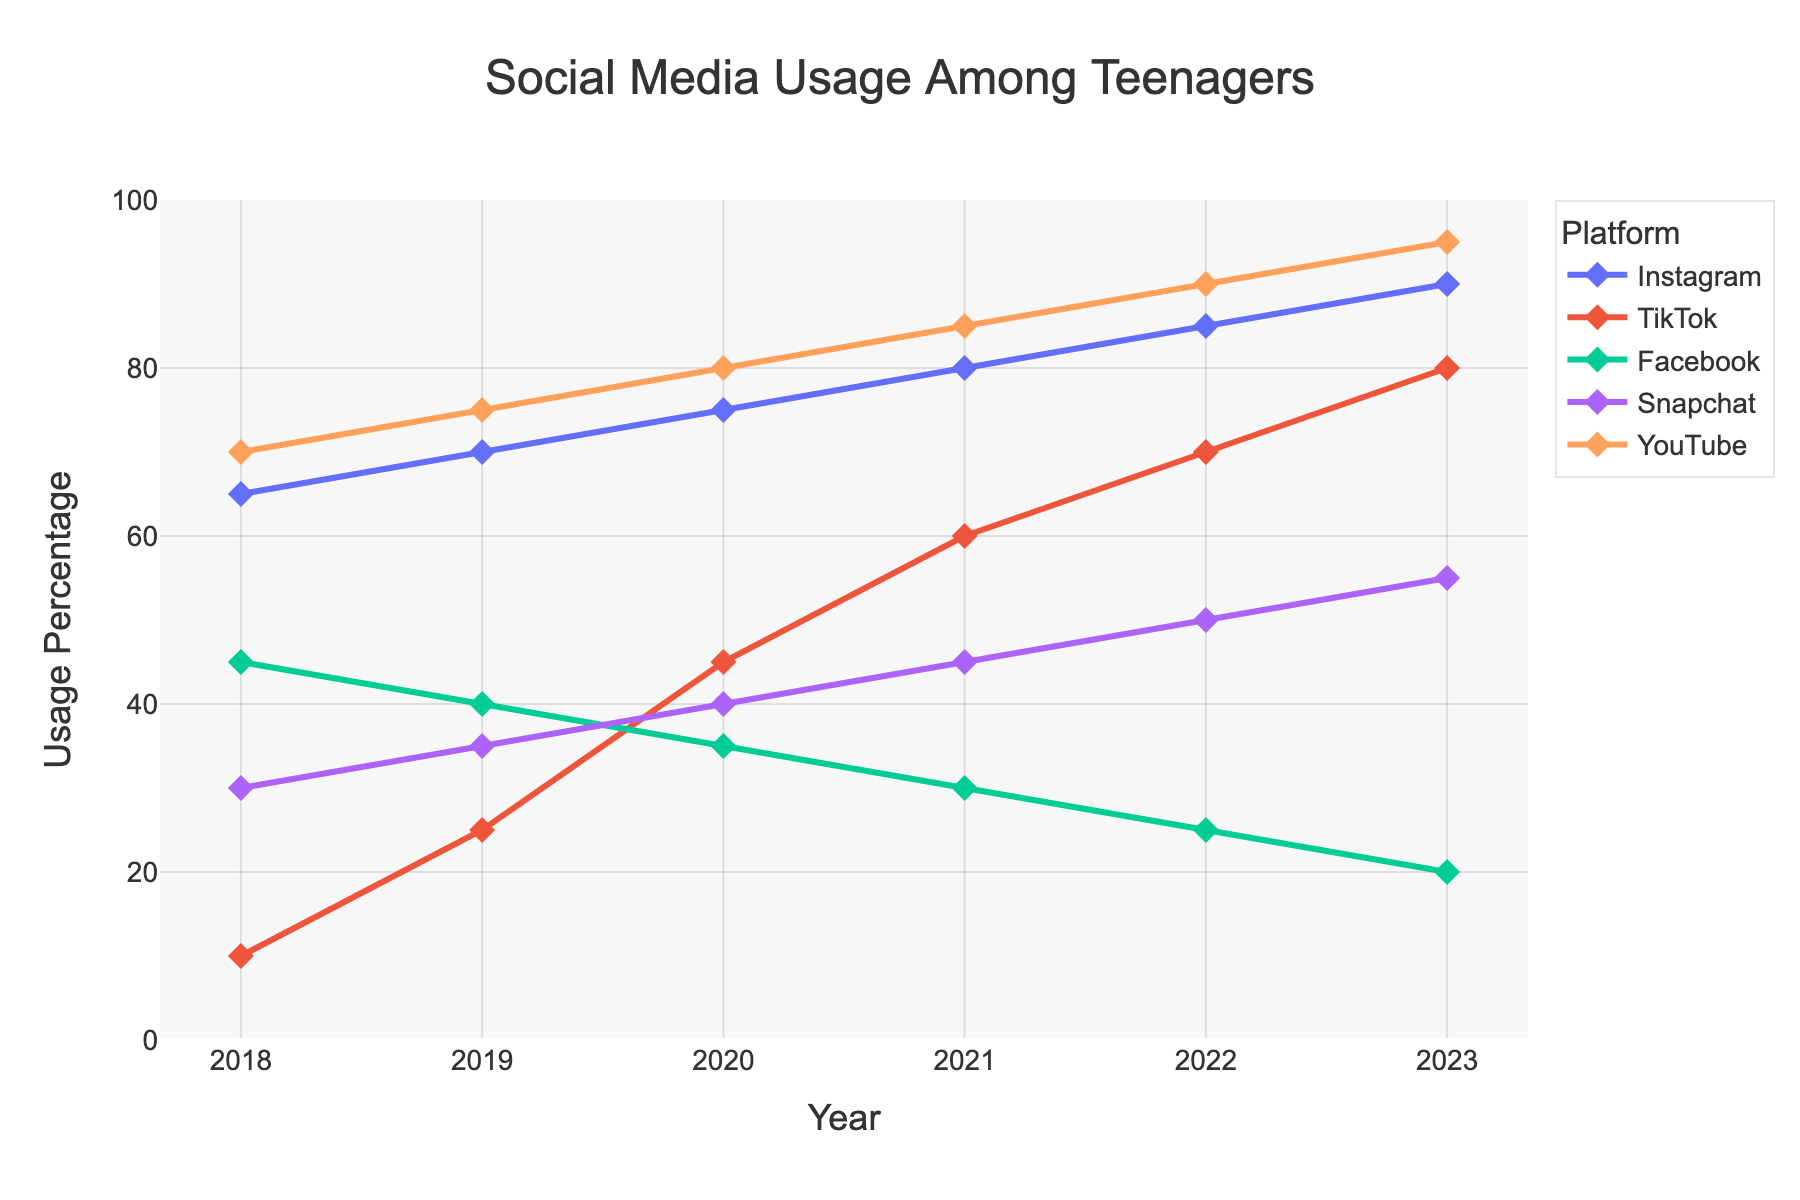What social media platform saw the highest increase in usage from 2018 to 2023? To find the highest increase in usage, we need to calculate the difference in usage percentage for each platform from 2018 to 2023. The differences are: Instagram (90 - 65) = 25, TikTok (80 - 10) = 70, Facebook (20 - 45) = -25, Snapchat (55 - 30) = 25, YouTube (95 - 70) = 25. TikTok has the highest increase of 70%.
Answer: TikTok Which social media platform had the lowest usage in 2023? Check the percentages for all platforms in 2023. The values are Instagram (90), TikTok (80), Facebook (20), Snapchat (55), YouTube (95). Facebook has the lowest usage at 20%.
Answer: Facebook How many social media platforms had an increase in usage each year from 2018 to 2023? Review the percentage values of each platform year by year to see if they consistently increased. Instagram, TikTok, Snapchat, and YouTube all show consistent yearly increases. Facebook does not.
Answer: 4 In which year did TikTok surpass Facebook in usage? Compare the usage percentages of TikTok and Facebook year by year. In 2018, the values are TikTok (10) and Facebook (45). In 2019, TikTok (25) and Facebook (40). In 2020, TikTok (45) surpasses Facebook (35).
Answer: 2020 Which platform had the most stable usage trend from 2018 to 2023? The most stable trend would have the smallest changes in values. We look at the ranges: Instagram (90-65=25), TikTok (80-10=70), Facebook (45-20=25), Snapchat (55-30=25), YouTube (95-70=25). Instagram, Facebook, Snapchat, and YouTube all have equal changes. However, Facebook usage decreased, suggesting it's less stable. Hence, Instagram, Snapchat, and YouTube are equally stable.
Answer: Instagram, Snapchat, and YouTube What is the average usage percentage of Snapchat from 2018 to 2023? Calculate the average by summing the values for Snapchat for each year and dividing by the number of years. (30+35+40+45+50+55) / 6 = 255 / 6 = 42.5.
Answer: 42.5 Between Instagram and YouTube, which had a higher starting usage in 2018 and by how much? Compare the usage values in 2018: Instagram (65) and YouTube (70). YouTube is higher. The difference is 70-65=5.
Answer: YouTube, 5 Did any platform's usage decrease between any two consecutive years? Examine the year-over-year values for each platform. Facebook shows a decrease every consecutive year from 2018 to 2023 (45 to 20).
Answer: Yes, Facebook Which platform had the highest usage in 2019, and what was its percentage? Compare the usage values for all platforms in 2019: Instagram (70), TikTok (25), Facebook (40), Snapchat (35), YouTube (75). YouTube had the highest usage at 75%.
Answer: YouTube, 75 